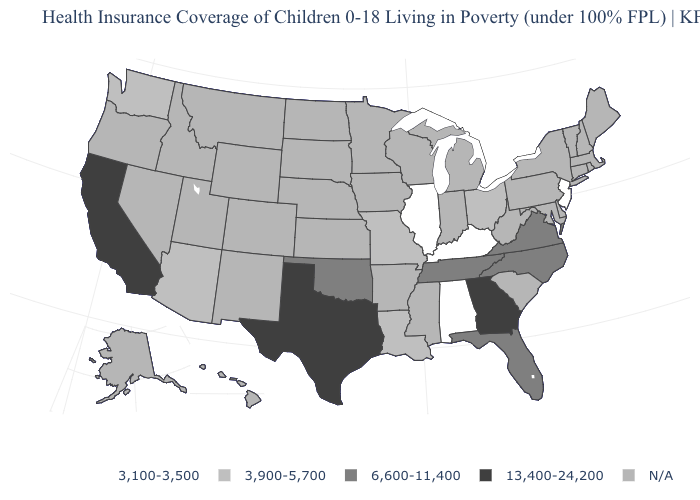Name the states that have a value in the range 3,100-3,500?
Keep it brief. Alabama, Illinois, Kentucky, New Jersey. Name the states that have a value in the range 13,400-24,200?
Short answer required. California, Georgia, Texas. Does California have the highest value in the USA?
Give a very brief answer. Yes. Name the states that have a value in the range 13,400-24,200?
Give a very brief answer. California, Georgia, Texas. What is the lowest value in the USA?
Keep it brief. 3,100-3,500. What is the value of Pennsylvania?
Quick response, please. N/A. Name the states that have a value in the range 13,400-24,200?
Short answer required. California, Georgia, Texas. Which states hav the highest value in the West?
Short answer required. California. Name the states that have a value in the range 3,100-3,500?
Answer briefly. Alabama, Illinois, Kentucky, New Jersey. Does Texas have the highest value in the South?
Give a very brief answer. Yes. What is the value of Maine?
Keep it brief. N/A. Name the states that have a value in the range 3,100-3,500?
Give a very brief answer. Alabama, Illinois, Kentucky, New Jersey. 